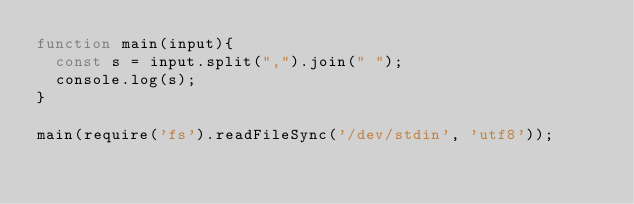Convert code to text. <code><loc_0><loc_0><loc_500><loc_500><_JavaScript_>function main(input){
  const s = input.split(",").join(" ");
  console.log(s);
}

main(require('fs').readFileSync('/dev/stdin', 'utf8'));</code> 